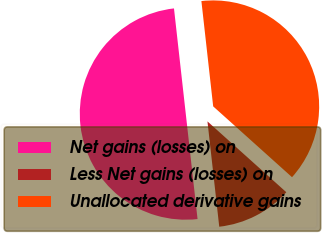Convert chart. <chart><loc_0><loc_0><loc_500><loc_500><pie_chart><fcel>Net gains (losses) on<fcel>Less Net gains (losses) on<fcel>Unallocated derivative gains<nl><fcel>50.0%<fcel>11.58%<fcel>38.42%<nl></chart> 